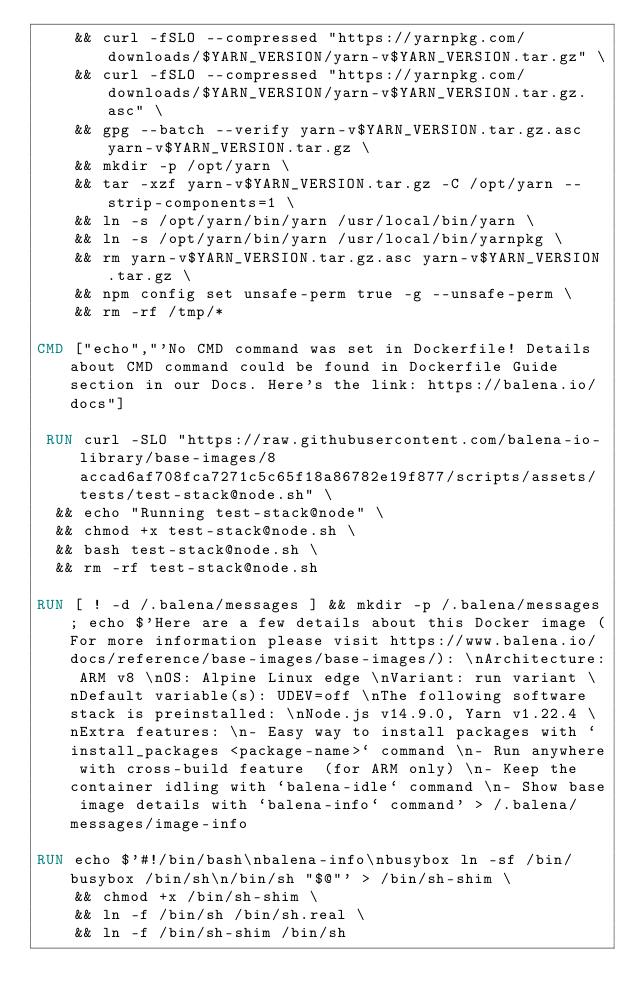<code> <loc_0><loc_0><loc_500><loc_500><_Dockerfile_>	&& curl -fSLO --compressed "https://yarnpkg.com/downloads/$YARN_VERSION/yarn-v$YARN_VERSION.tar.gz" \
	&& curl -fSLO --compressed "https://yarnpkg.com/downloads/$YARN_VERSION/yarn-v$YARN_VERSION.tar.gz.asc" \
	&& gpg --batch --verify yarn-v$YARN_VERSION.tar.gz.asc yarn-v$YARN_VERSION.tar.gz \
	&& mkdir -p /opt/yarn \
	&& tar -xzf yarn-v$YARN_VERSION.tar.gz -C /opt/yarn --strip-components=1 \
	&& ln -s /opt/yarn/bin/yarn /usr/local/bin/yarn \
	&& ln -s /opt/yarn/bin/yarn /usr/local/bin/yarnpkg \
	&& rm yarn-v$YARN_VERSION.tar.gz.asc yarn-v$YARN_VERSION.tar.gz \
	&& npm config set unsafe-perm true -g --unsafe-perm \
	&& rm -rf /tmp/*

CMD ["echo","'No CMD command was set in Dockerfile! Details about CMD command could be found in Dockerfile Guide section in our Docs. Here's the link: https://balena.io/docs"]

 RUN curl -SLO "https://raw.githubusercontent.com/balena-io-library/base-images/8accad6af708fca7271c5c65f18a86782e19f877/scripts/assets/tests/test-stack@node.sh" \
  && echo "Running test-stack@node" \
  && chmod +x test-stack@node.sh \
  && bash test-stack@node.sh \
  && rm -rf test-stack@node.sh 

RUN [ ! -d /.balena/messages ] && mkdir -p /.balena/messages; echo $'Here are a few details about this Docker image (For more information please visit https://www.balena.io/docs/reference/base-images/base-images/): \nArchitecture: ARM v8 \nOS: Alpine Linux edge \nVariant: run variant \nDefault variable(s): UDEV=off \nThe following software stack is preinstalled: \nNode.js v14.9.0, Yarn v1.22.4 \nExtra features: \n- Easy way to install packages with `install_packages <package-name>` command \n- Run anywhere with cross-build feature  (for ARM only) \n- Keep the container idling with `balena-idle` command \n- Show base image details with `balena-info` command' > /.balena/messages/image-info

RUN echo $'#!/bin/bash\nbalena-info\nbusybox ln -sf /bin/busybox /bin/sh\n/bin/sh "$@"' > /bin/sh-shim \
	&& chmod +x /bin/sh-shim \
	&& ln -f /bin/sh /bin/sh.real \
	&& ln -f /bin/sh-shim /bin/sh</code> 